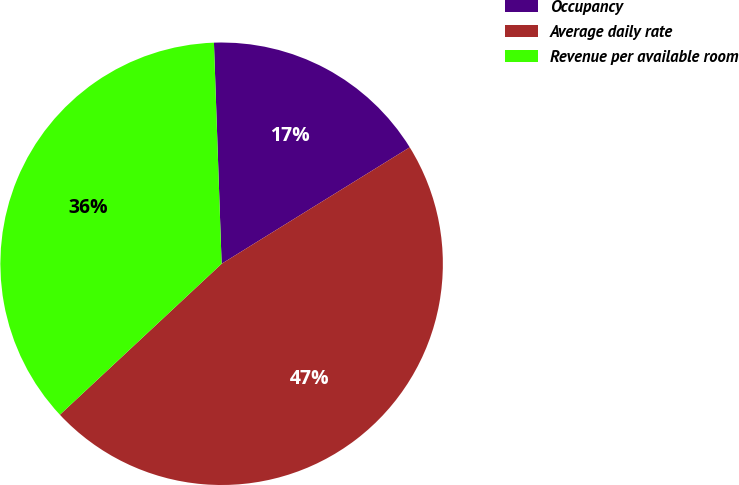Convert chart. <chart><loc_0><loc_0><loc_500><loc_500><pie_chart><fcel>Occupancy<fcel>Average daily rate<fcel>Revenue per available room<nl><fcel>16.73%<fcel>46.87%<fcel>36.4%<nl></chart> 